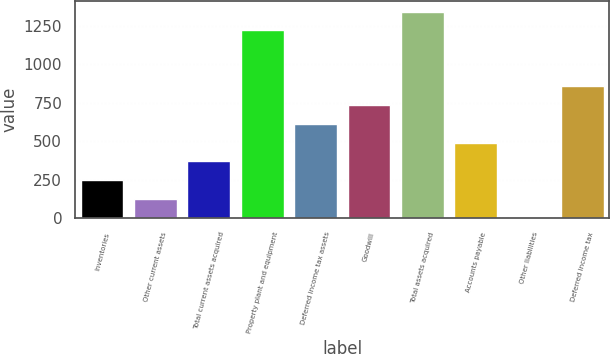<chart> <loc_0><loc_0><loc_500><loc_500><bar_chart><fcel>Inventories<fcel>Other current assets<fcel>Total current assets acquired<fcel>Property plant and equipment<fcel>Deferred income tax assets<fcel>Goodwill<fcel>Total assets acquired<fcel>Accounts payable<fcel>Other liabilities<fcel>Deferred income tax<nl><fcel>248.8<fcel>127.4<fcel>370.2<fcel>1220<fcel>613<fcel>734.4<fcel>1341.4<fcel>491.6<fcel>6<fcel>855.8<nl></chart> 